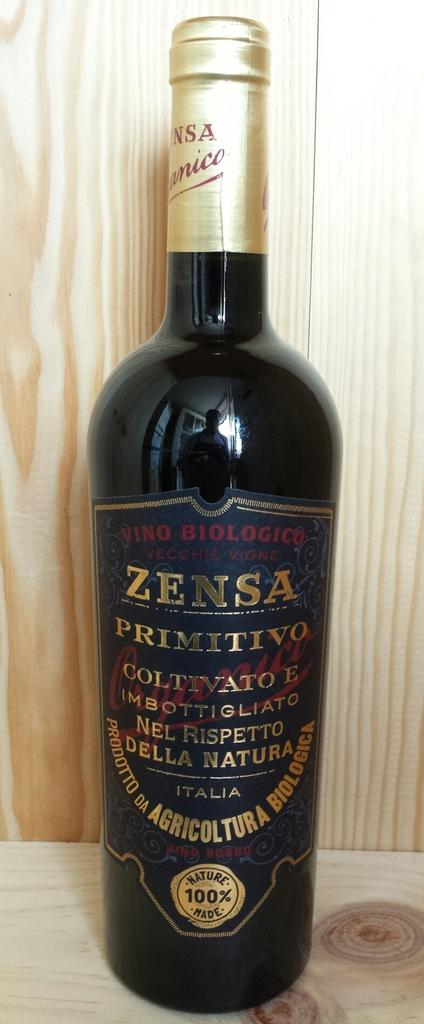<image>
Create a compact narrative representing the image presented. An unopened bottle of Zensa Primitivo wine from Italy that is 100% Nature Made. 